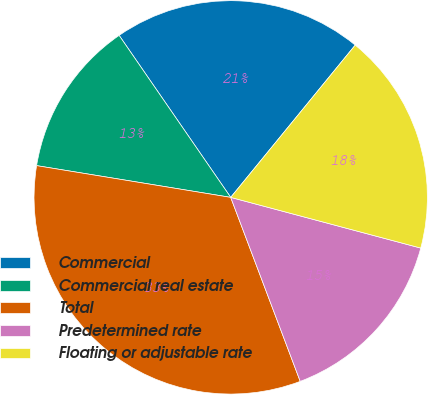Convert chart. <chart><loc_0><loc_0><loc_500><loc_500><pie_chart><fcel>Commercial<fcel>Commercial real estate<fcel>Total<fcel>Predetermined rate<fcel>Floating or adjustable rate<nl><fcel>20.51%<fcel>12.82%<fcel>33.33%<fcel>15.1%<fcel>18.24%<nl></chart> 